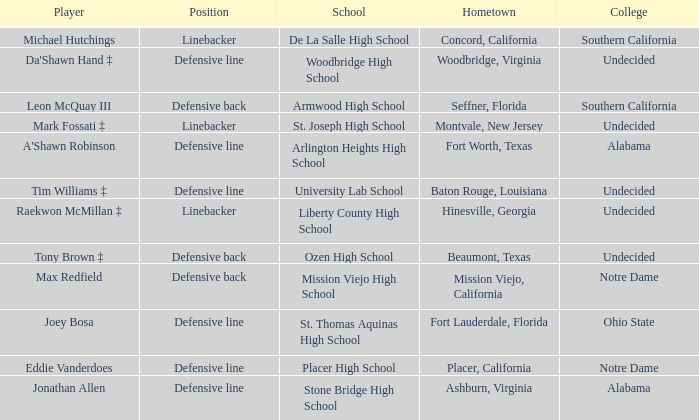What is the position of the player from Fort Lauderdale, Florida? Defensive line. 